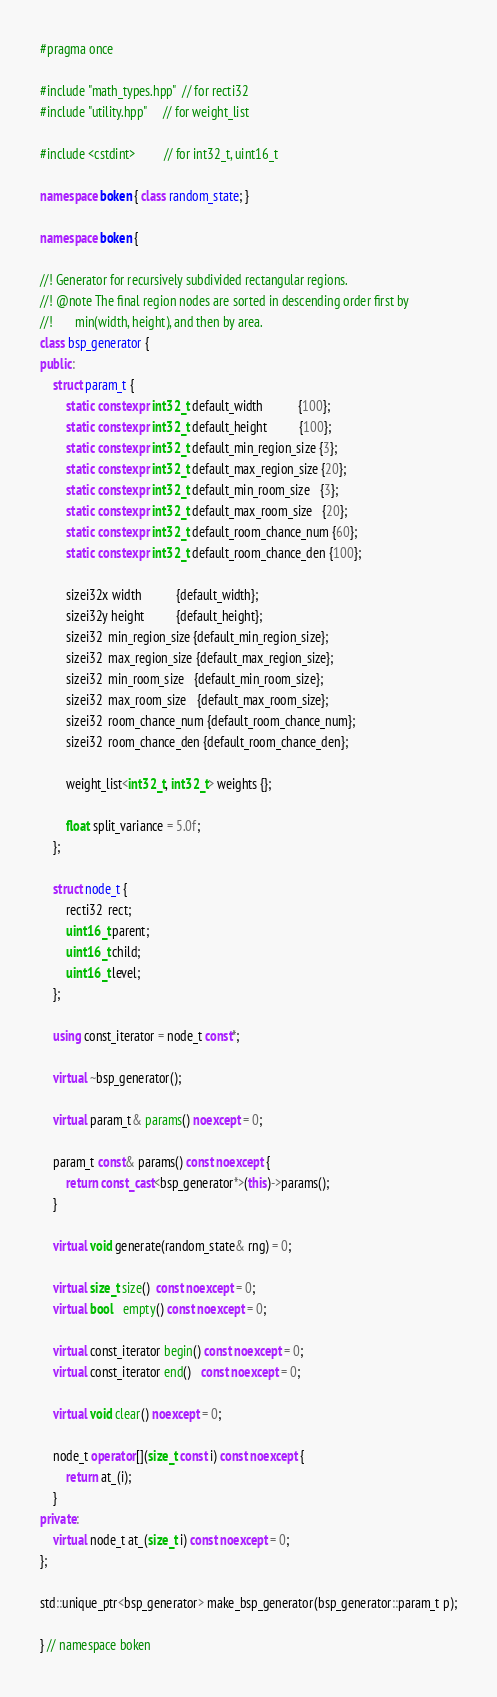Convert code to text. <code><loc_0><loc_0><loc_500><loc_500><_C++_>#pragma once

#include "math_types.hpp"  // for recti32
#include "utility.hpp"     // for weight_list

#include <cstdint>         // for int32_t, uint16_t

namespace boken { class random_state; }

namespace boken {

//! Generator for recursively subdivided rectangular regions.
//! @note The final region nodes are sorted in descending order first by
//!       min(width, height), and then by area.
class bsp_generator {
public:
    struct param_t {
        static constexpr int32_t default_width           {100};
        static constexpr int32_t default_height          {100};
        static constexpr int32_t default_min_region_size {3};
        static constexpr int32_t default_max_region_size {20};
        static constexpr int32_t default_min_room_size   {3};
        static constexpr int32_t default_max_room_size   {20};
        static constexpr int32_t default_room_chance_num {60};
        static constexpr int32_t default_room_chance_den {100};

        sizei32x width           {default_width};
        sizei32y height          {default_height};
        sizei32  min_region_size {default_min_region_size};
        sizei32  max_region_size {default_max_region_size};
        sizei32  min_room_size   {default_min_room_size};
        sizei32  max_room_size   {default_max_room_size};
        sizei32  room_chance_num {default_room_chance_num};
        sizei32  room_chance_den {default_room_chance_den};

        weight_list<int32_t, int32_t> weights {};

        float split_variance = 5.0f;
    };

    struct node_t {
        recti32  rect;
        uint16_t parent;
        uint16_t child;
        uint16_t level;
    };

    using const_iterator = node_t const*;

    virtual ~bsp_generator();

    virtual param_t& params() noexcept = 0;

    param_t const& params() const noexcept {
        return const_cast<bsp_generator*>(this)->params();
    }

    virtual void generate(random_state& rng) = 0;

    virtual size_t size()  const noexcept = 0;
    virtual bool   empty() const noexcept = 0;

    virtual const_iterator begin() const noexcept = 0;
    virtual const_iterator end()   const noexcept = 0;

    virtual void clear() noexcept = 0;

    node_t operator[](size_t const i) const noexcept {
        return at_(i);
    }
private:
    virtual node_t at_(size_t i) const noexcept = 0;
};

std::unique_ptr<bsp_generator> make_bsp_generator(bsp_generator::param_t p);

} // namespace boken
</code> 